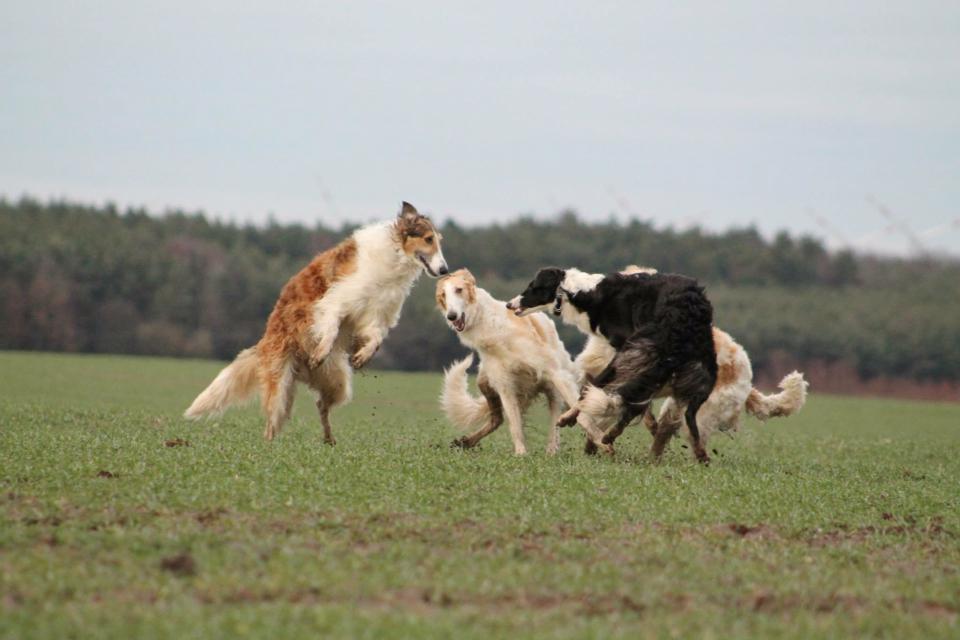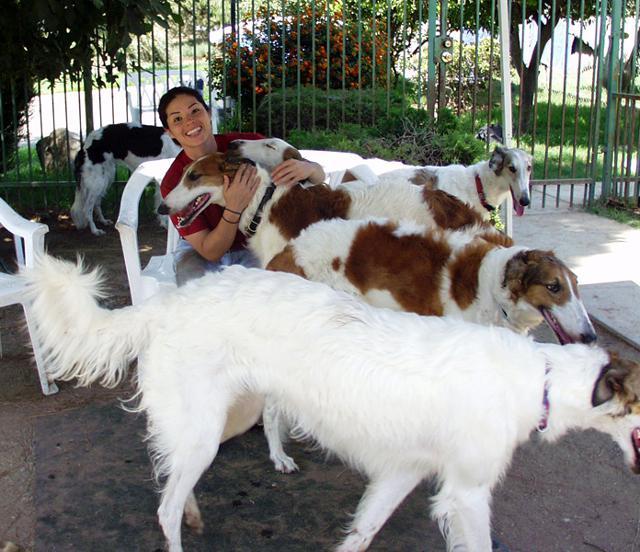The first image is the image on the left, the second image is the image on the right. Examine the images to the left and right. Is the description "At least one person is outside with the dogs in the image on the right." accurate? Answer yes or no. Yes. The first image is the image on the left, the second image is the image on the right. Analyze the images presented: Is the assertion "A group of dogs is playing outside, and at least two dogs have both front paws off the ground." valid? Answer yes or no. Yes. 